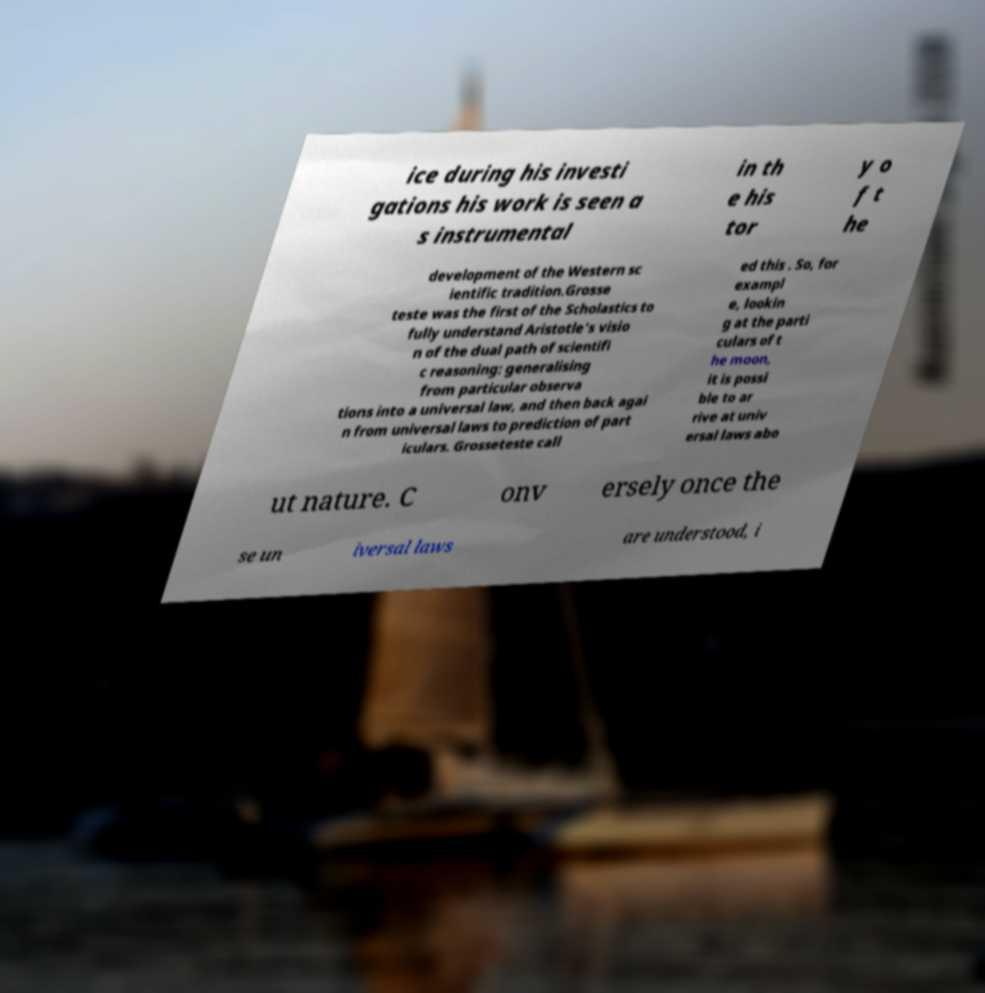What messages or text are displayed in this image? I need them in a readable, typed format. ice during his investi gations his work is seen a s instrumental in th e his tor y o f t he development of the Western sc ientific tradition.Grosse teste was the first of the Scholastics to fully understand Aristotle's visio n of the dual path of scientifi c reasoning: generalising from particular observa tions into a universal law, and then back agai n from universal laws to prediction of part iculars. Grosseteste call ed this . So, for exampl e, lookin g at the parti culars of t he moon, it is possi ble to ar rive at univ ersal laws abo ut nature. C onv ersely once the se un iversal laws are understood, i 